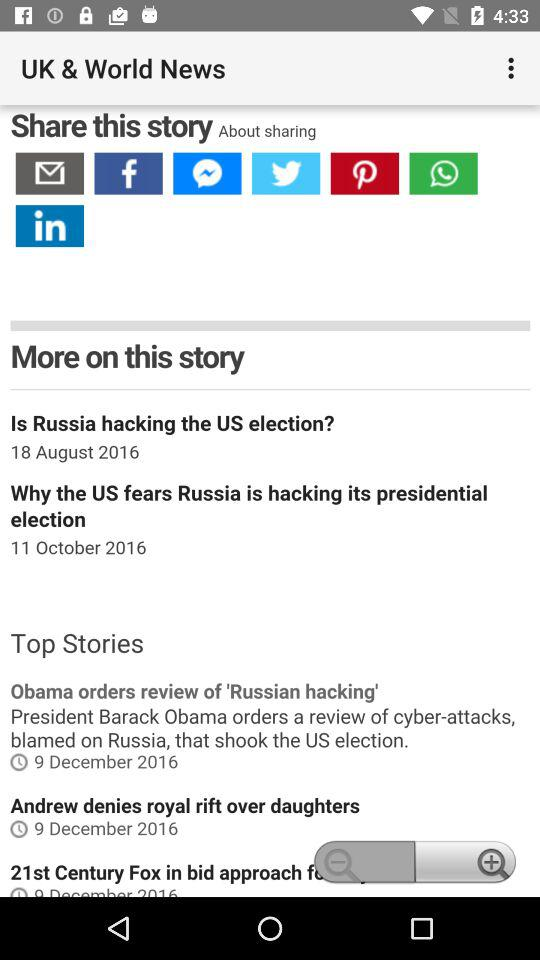Which app can be chosen to share? The apps are "Facebook", "Messenger", "Twitter", "Pinterest", "WhatsApp Messenger" and "LinkedIn". 